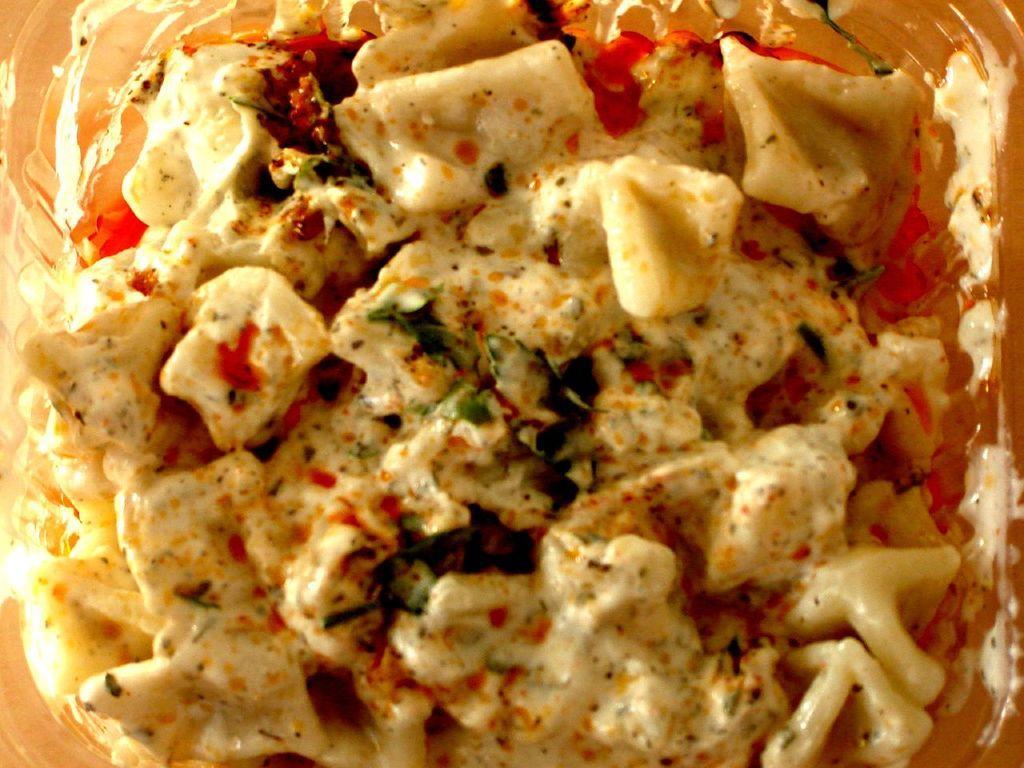Can you describe this image briefly? In this picture I can see food in the bowl with some sauces. 